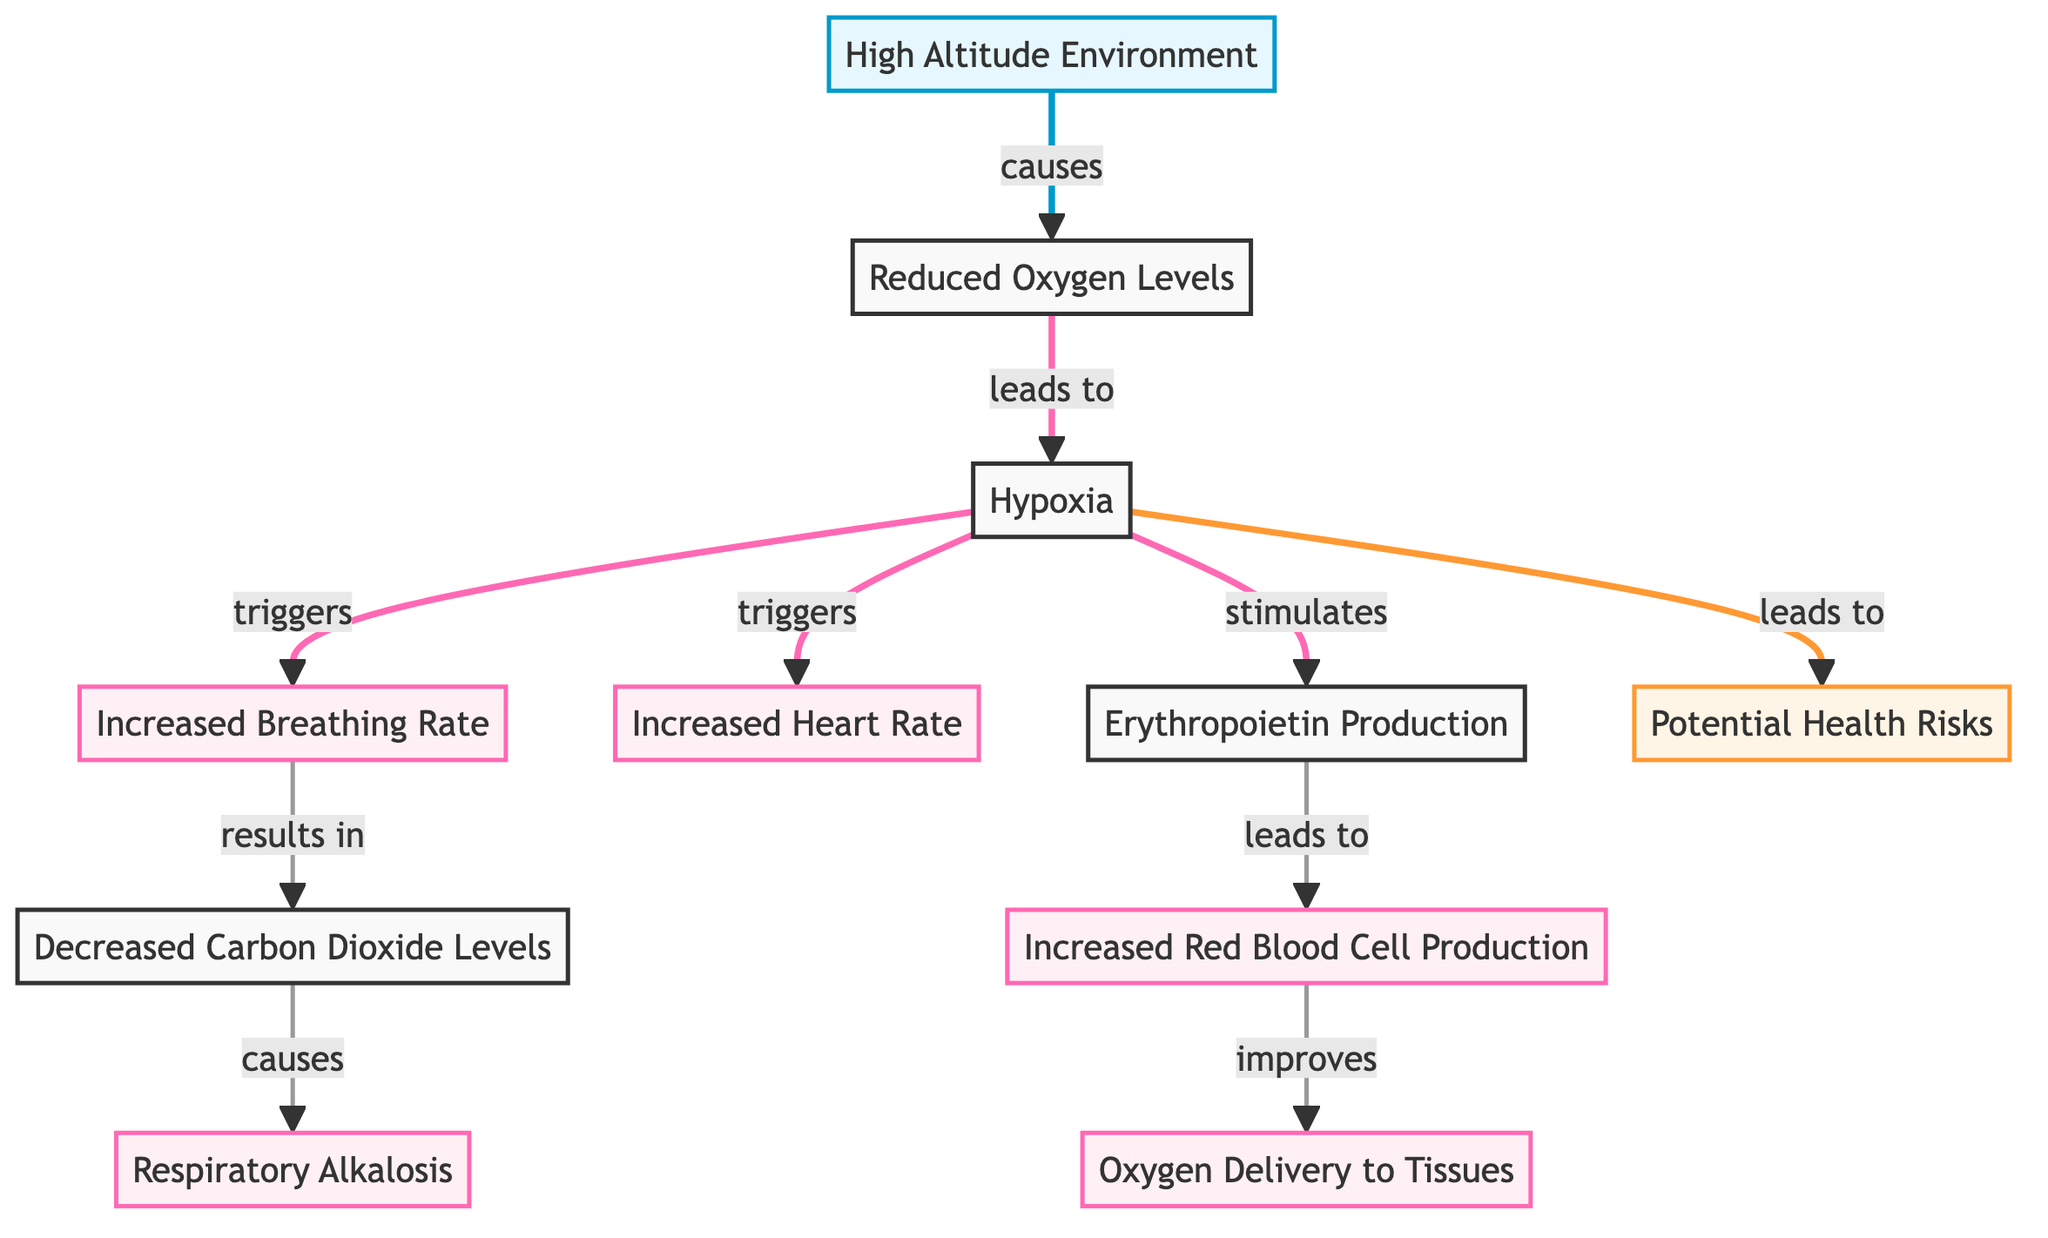What does the High Altitude Environment cause? In the diagram, the arrow indicates a cause-and-effect relationship from "High Altitude Environment" to "Reduced Oxygen Levels," meaning the high altitude environment leads to reduced oxygen levels.
Answer: Reduced Oxygen Levels How many physiological effects are listed in the diagram? The diagram lists five distinct physiological effects: increased breathing rate, increased heart rate, increased red blood cell production, decreased carbon dioxide levels, and respiratory alkalosis. Counting these effects gives a total of five.
Answer: 5 Which factor leads to potential health risks? The diagram shows that "Hypoxia" leads to "Potential Health Risks," establishing a direct cause for these health risks. Therefore, hypoxia is the contributing factor that leads to potential health risks.
Answer: Hypoxia What is produced as a response to hypoxia? The diagram indicates that hypoxia stimulates the production of erythropoietin, which is a key response in the body to compensate for reduced oxygen levels. Therefore, erythropoietin is produced in response to hypoxia.
Answer: Erythropoietin What effect does increased red blood cell production have? According to the diagram, increased red blood cell production improves oxygen delivery to tissues, indicating a beneficial effect of this physiological change. Therefore, it improves oxygen delivery.
Answer: Improves oxygen delivery to tissues What sequence of events follows reduced oxygen levels? Starting from "Reduced Oxygen Levels," the diagram indicates that this leads to hypoxia, which subsequently triggers increased breathing rate, increased heart rate, and the production of erythropoietin. The correct sequence is: hypoxia, increased breathing rate, increased heart rate, erythropoietin.
Answer: Hypoxia → Increased Breathing Rate, Increased Heart Rate, Erythropoietin How does respiratory alkalosis occur? The diagram outlines that when carbon dioxide levels decrease as a result of increased breathing rate, this leads to respiratory alkalosis. The process is first indicated by decreased carbon dioxide levels, subsequently resulting in respiratory alkalosis.
Answer: Decreased Carbon Dioxide Levels What effect does hypoxia have on heart rate? The diagram shows that hypoxia triggers an increased heart rate, indicating a direct relationship where hypoxia causes the heart rate to increase.
Answer: Increased Heart Rate Which node in the diagram is associated with lower oxygen levels? The node directly associated with lower oxygen levels is "Reduced Oxygen Levels," which shows the effect of the high altitude environment.
Answer: Reduced Oxygen Levels 